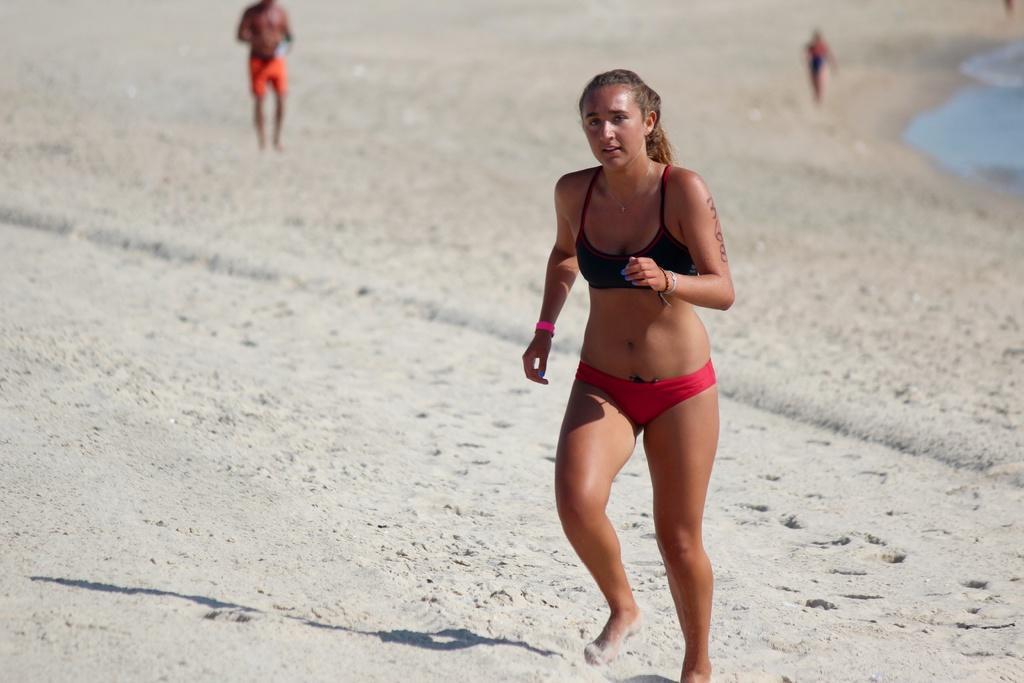Describe this image in one or two sentences. This image is taken in the beach. In this image there is a woman running in the sand by wearing the bikini. In the background there are two other persons walking on the sand. On the right side top corner there is water. 